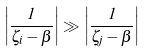<formula> <loc_0><loc_0><loc_500><loc_500>\left | \frac { 1 } { \zeta _ { i } - \beta } \right | \gg \left | \frac { 1 } { \zeta _ { j } - \beta } \right |</formula> 